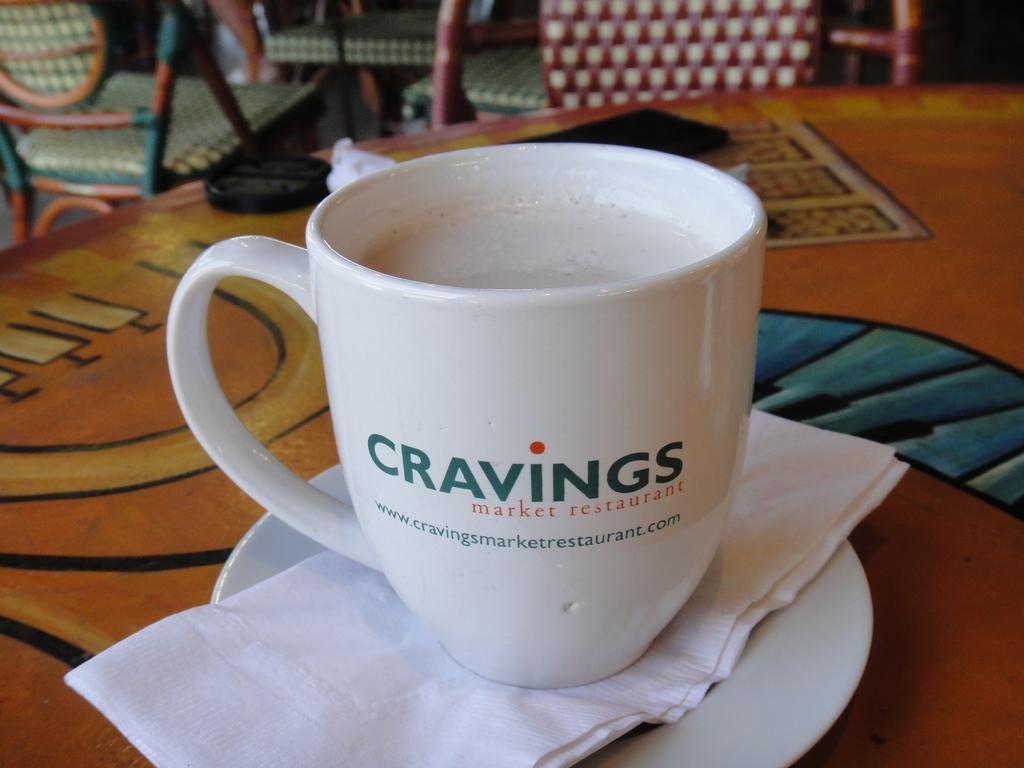What is one of the main objects in the image? There is a cup present in the image. What is placed alongside the cup? Tissue paper and a saucer are visible in the image. What can be inferred about the arrangement of the objects in the image? These objects are placed on a platform. What is visible in the background of the image? Chairs are present in the background of the image. How deep is the hole in the cup in the image? There is no hole in the cup in the image; it is a solid object. What type of sponge can be seen in the image? There is no sponge present in the image. 